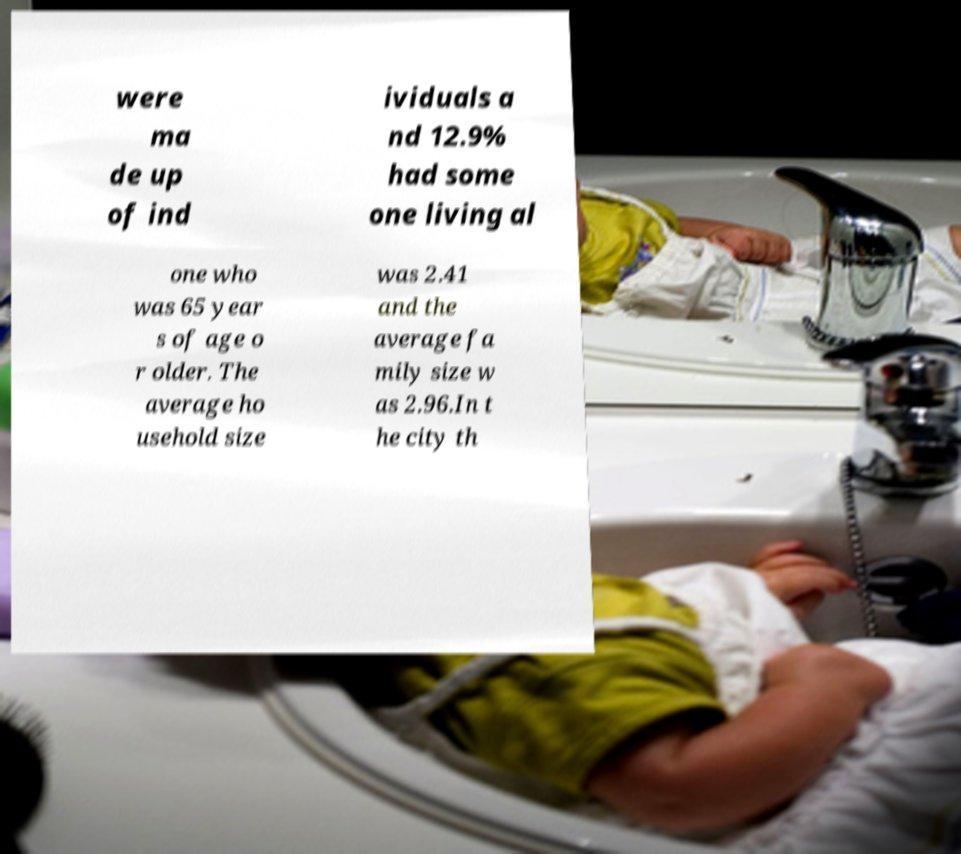Can you accurately transcribe the text from the provided image for me? were ma de up of ind ividuals a nd 12.9% had some one living al one who was 65 year s of age o r older. The average ho usehold size was 2.41 and the average fa mily size w as 2.96.In t he city th 